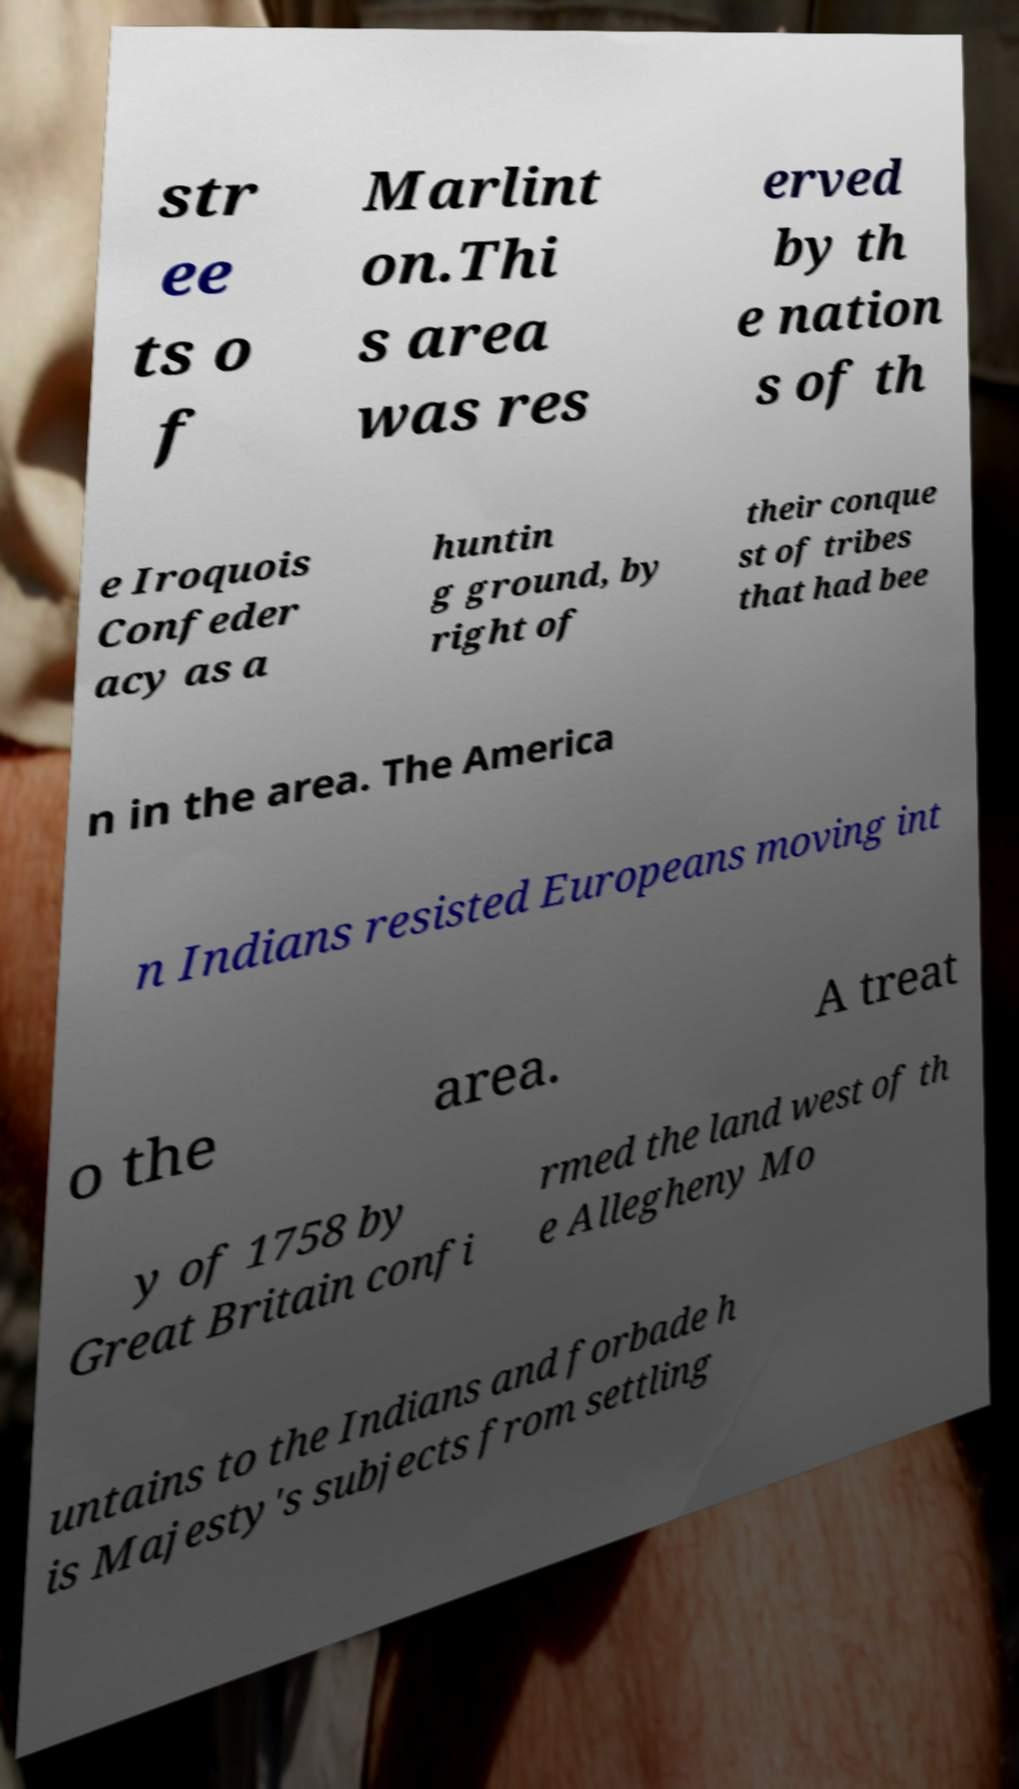Please read and relay the text visible in this image. What does it say? str ee ts o f Marlint on.Thi s area was res erved by th e nation s of th e Iroquois Confeder acy as a huntin g ground, by right of their conque st of tribes that had bee n in the area. The America n Indians resisted Europeans moving int o the area. A treat y of 1758 by Great Britain confi rmed the land west of th e Allegheny Mo untains to the Indians and forbade h is Majesty's subjects from settling 